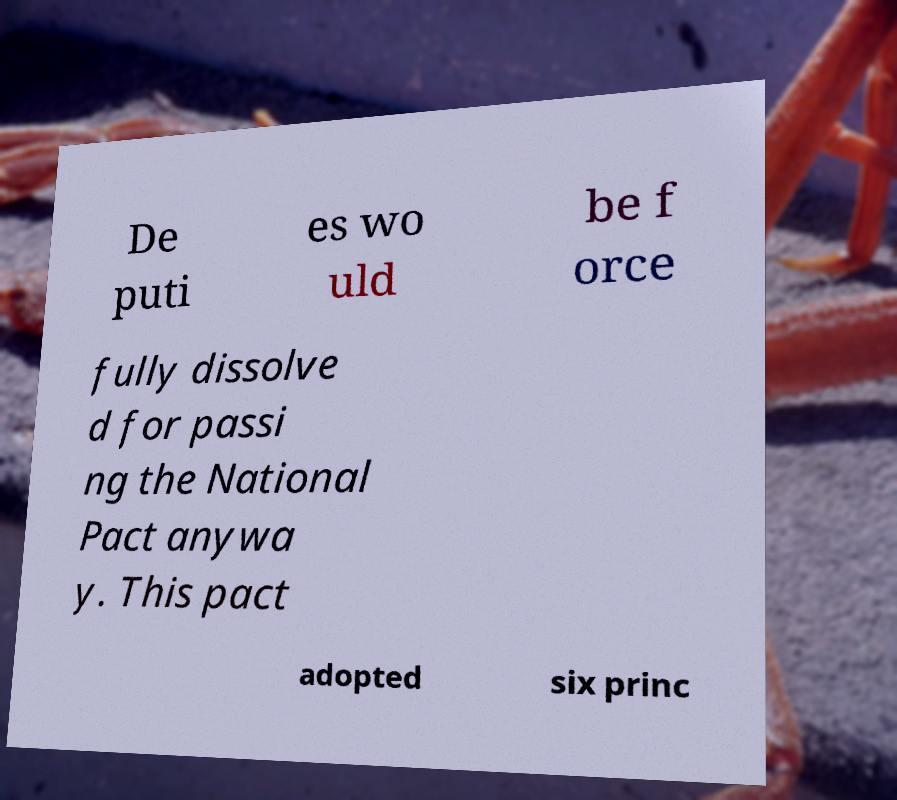There's text embedded in this image that I need extracted. Can you transcribe it verbatim? De puti es wo uld be f orce fully dissolve d for passi ng the National Pact anywa y. This pact adopted six princ 